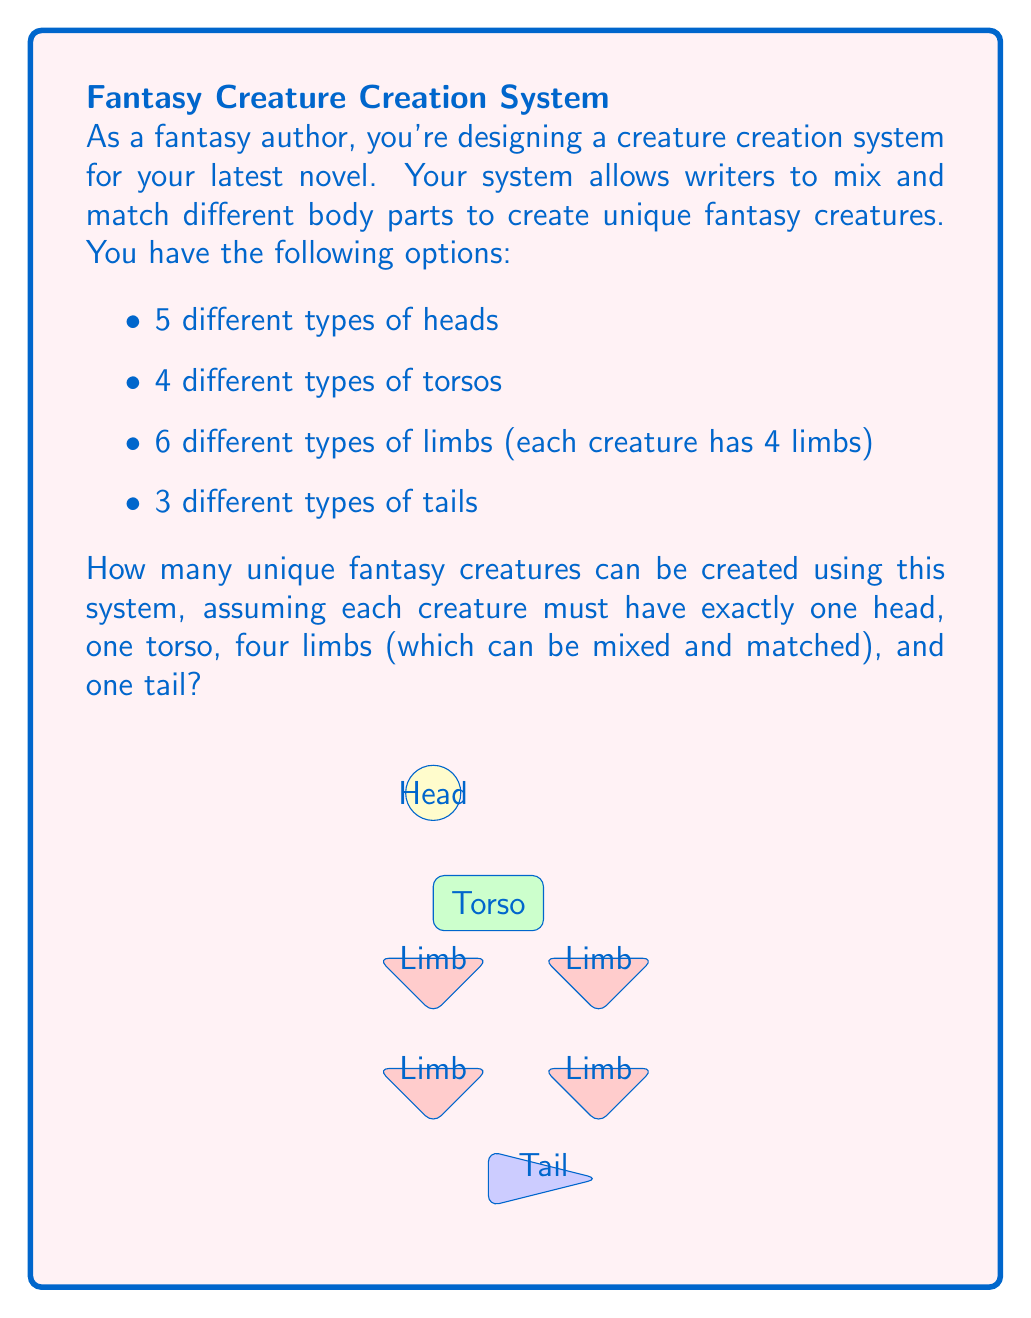Teach me how to tackle this problem. Let's break this down step-by-step:

1) For the head, we have 5 choices.

2) For the torso, we have 4 choices.

3) For the limbs, we have 6 choices for each of the 4 limbs. This is a case of repetition allowed, as we can use the same limb type multiple times. The number of ways to choose 4 limbs from 6 types with repetition allowed is given by the combination with repetition formula:

   $$\binom{n+r-1}{r} = \binom{6+4-1}{4} = \binom{9}{4} = 126$$

4) For the tail, we have 3 choices.

5) According to the multiplication principle, if we have a ways of doing something, b ways of doing another thing, c ways of doing a third thing, and so on, then there are $a \times b \times c \times ...$ ways to do all of these things.

Therefore, the total number of unique creatures is:

$$5 \times 4 \times 126 \times 3 = 7,560$$
Answer: 7,560 unique creatures 